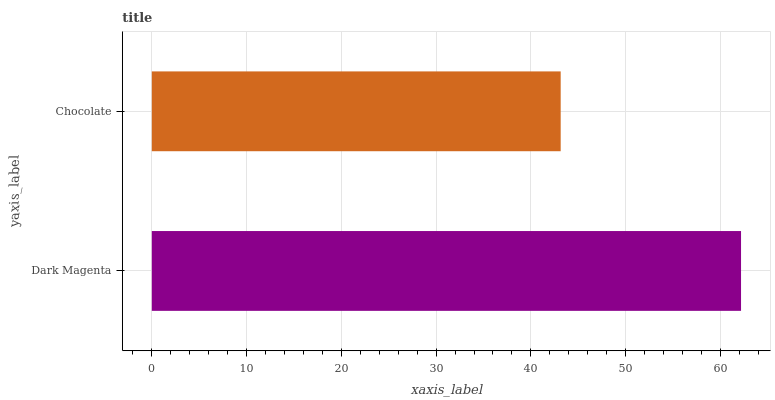Is Chocolate the minimum?
Answer yes or no. Yes. Is Dark Magenta the maximum?
Answer yes or no. Yes. Is Chocolate the maximum?
Answer yes or no. No. Is Dark Magenta greater than Chocolate?
Answer yes or no. Yes. Is Chocolate less than Dark Magenta?
Answer yes or no. Yes. Is Chocolate greater than Dark Magenta?
Answer yes or no. No. Is Dark Magenta less than Chocolate?
Answer yes or no. No. Is Dark Magenta the high median?
Answer yes or no. Yes. Is Chocolate the low median?
Answer yes or no. Yes. Is Chocolate the high median?
Answer yes or no. No. Is Dark Magenta the low median?
Answer yes or no. No. 